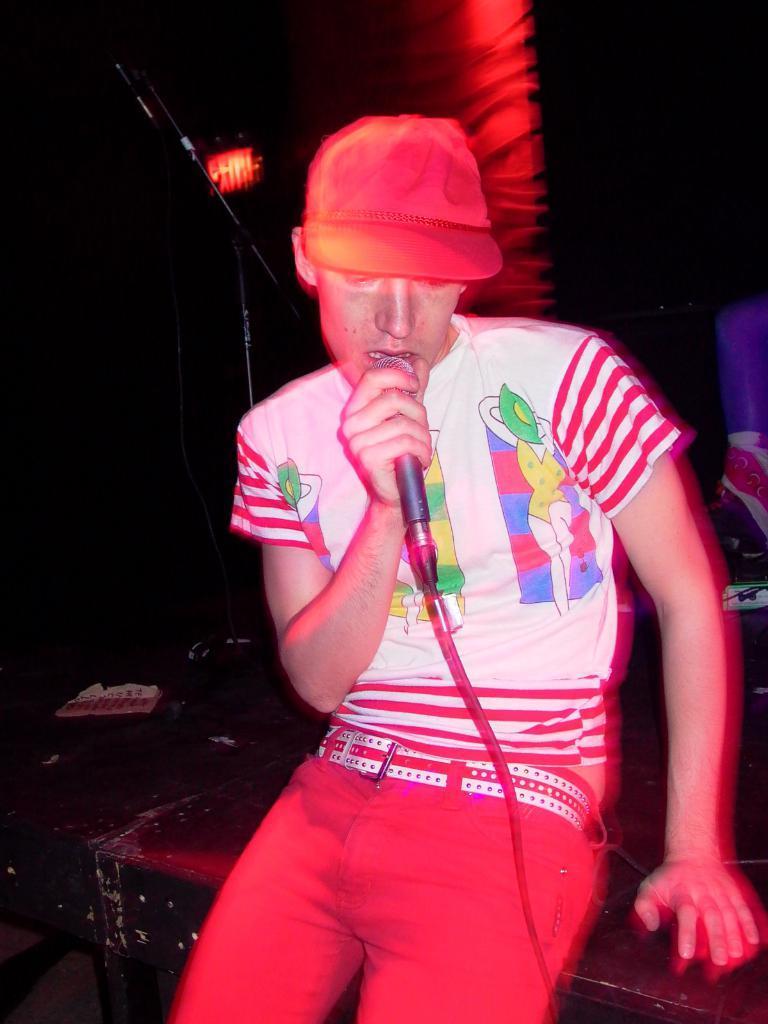How would you summarize this image in a sentence or two? In this image in the foreground we can see a person wearing a cap, holding a mike. In the background we can see dark. 